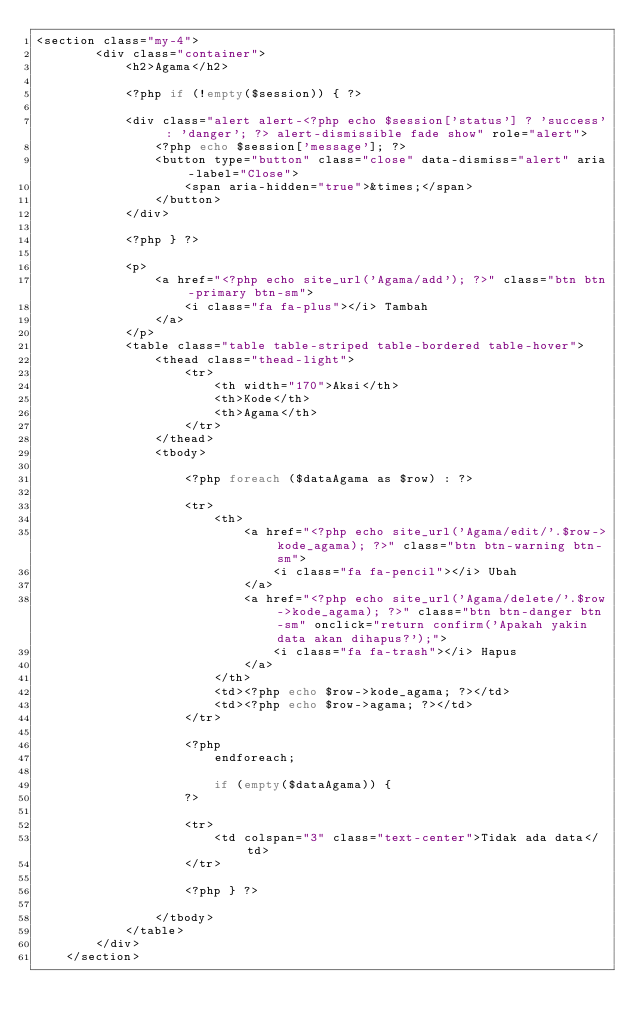<code> <loc_0><loc_0><loc_500><loc_500><_PHP_><section class="my-4">
        <div class="container">
            <h2>Agama</h2>
            
            <?php if (!empty($session)) { ?>

            <div class="alert alert-<?php echo $session['status'] ? 'success' : 'danger'; ?> alert-dismissible fade show" role="alert">
                <?php echo $session['message']; ?>
                <button type="button" class="close" data-dismiss="alert" aria-label="Close">
                    <span aria-hidden="true">&times;</span>
                </button>
            </div>

            <?php } ?>
            
            <p>
                <a href="<?php echo site_url('Agama/add'); ?>" class="btn btn-primary btn-sm">
                    <i class="fa fa-plus"></i> Tambah
                </a>
            </p>
            <table class="table table-striped table-bordered table-hover">
                <thead class="thead-light">
                    <tr>
                        <th width="170">Aksi</th>
                        <th>Kode</th>
                        <th>Agama</th>
                    </tr>
                </thead>
                <tbody>

                    <?php foreach ($dataAgama as $row) : ?>

                    <tr>
                        <th>
                            <a href="<?php echo site_url('Agama/edit/'.$row->kode_agama); ?>" class="btn btn-warning btn-sm">
                                <i class="fa fa-pencil"></i> Ubah
                            </a>
                            <a href="<?php echo site_url('Agama/delete/'.$row->kode_agama); ?>" class="btn btn-danger btn-sm" onclick="return confirm('Apakah yakin data akan dihapus?');">
                                <i class="fa fa-trash"></i> Hapus
                            </a>
                        </th>
                        <td><?php echo $row->kode_agama; ?></td>
                        <td><?php echo $row->agama; ?></td>
                    </tr>

                    <?php
                        endforeach;

                        if (empty($dataAgama)) {
                    ?>

                    <tr>
                        <td colspan="3" class="text-center">Tidak ada data</td>
                    </tr>

                    <?php } ?>
                    
                </tbody>
            </table>
        </div>
    </section></code> 